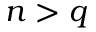Convert formula to latex. <formula><loc_0><loc_0><loc_500><loc_500>n > q</formula> 